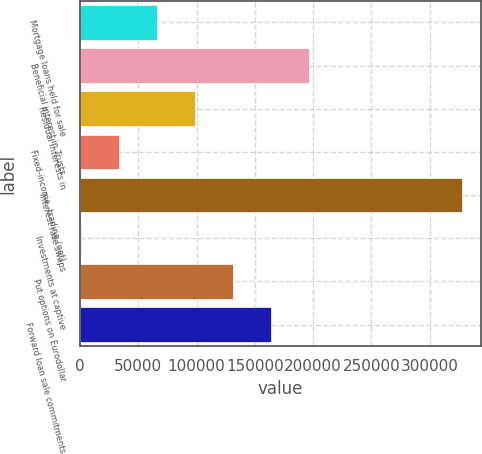Convert chart. <chart><loc_0><loc_0><loc_500><loc_500><bar_chart><fcel>Mortgage loans held for sale<fcel>Beneficial interest in Trusts<fcel>Residual interests in<fcel>Fixed-income -trading (net)<fcel>Interest rate swaps<fcel>Investments at captive<fcel>Put options on Eurodollar<fcel>Forward loan sale commitments<nl><fcel>66057.8<fcel>196727<fcel>98725.2<fcel>33390.4<fcel>327397<fcel>723<fcel>131393<fcel>164060<nl></chart> 